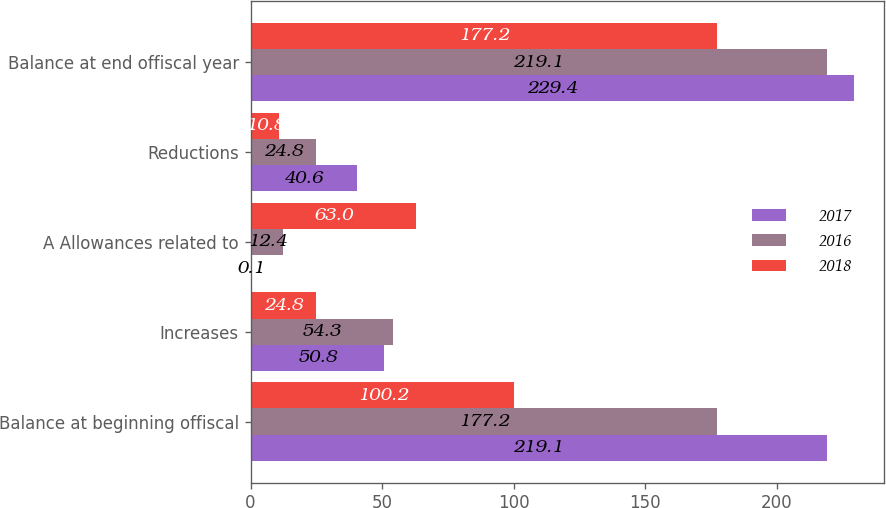Convert chart to OTSL. <chart><loc_0><loc_0><loc_500><loc_500><stacked_bar_chart><ecel><fcel>Balance at beginning offiscal<fcel>Increases<fcel>A Allowances related to<fcel>Reductions<fcel>Balance at end offiscal year<nl><fcel>2017<fcel>219.1<fcel>50.8<fcel>0.1<fcel>40.6<fcel>229.4<nl><fcel>2016<fcel>177.2<fcel>54.3<fcel>12.4<fcel>24.8<fcel>219.1<nl><fcel>2018<fcel>100.2<fcel>24.8<fcel>63<fcel>10.8<fcel>177.2<nl></chart> 